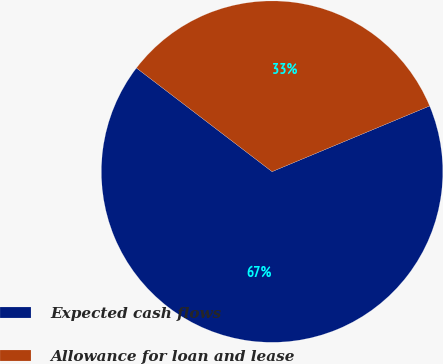Convert chart. <chart><loc_0><loc_0><loc_500><loc_500><pie_chart><fcel>Expected cash flows<fcel>Allowance for loan and lease<nl><fcel>66.67%<fcel>33.33%<nl></chart> 